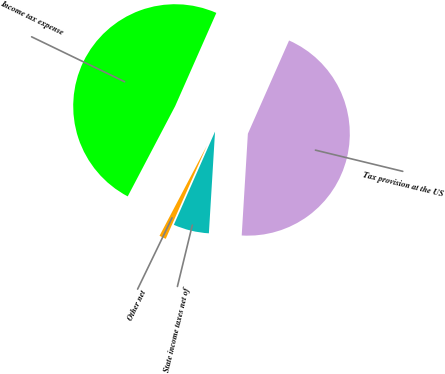<chart> <loc_0><loc_0><loc_500><loc_500><pie_chart><fcel>Tax provision at the US<fcel>State income taxes net of<fcel>Other net<fcel>Income tax expense<nl><fcel>44.34%<fcel>5.66%<fcel>1.08%<fcel>48.92%<nl></chart> 